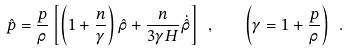<formula> <loc_0><loc_0><loc_500><loc_500>\hat { p } = \frac { p } { \rho } \left [ \left ( 1 + \frac { n } { \gamma } \right ) \hat { \rho } + \frac { n } { 3 \gamma H } \dot { \hat { \rho } } \right ] \ , \quad \left ( \gamma = 1 + \frac { p } { \rho } \right ) \ .</formula> 